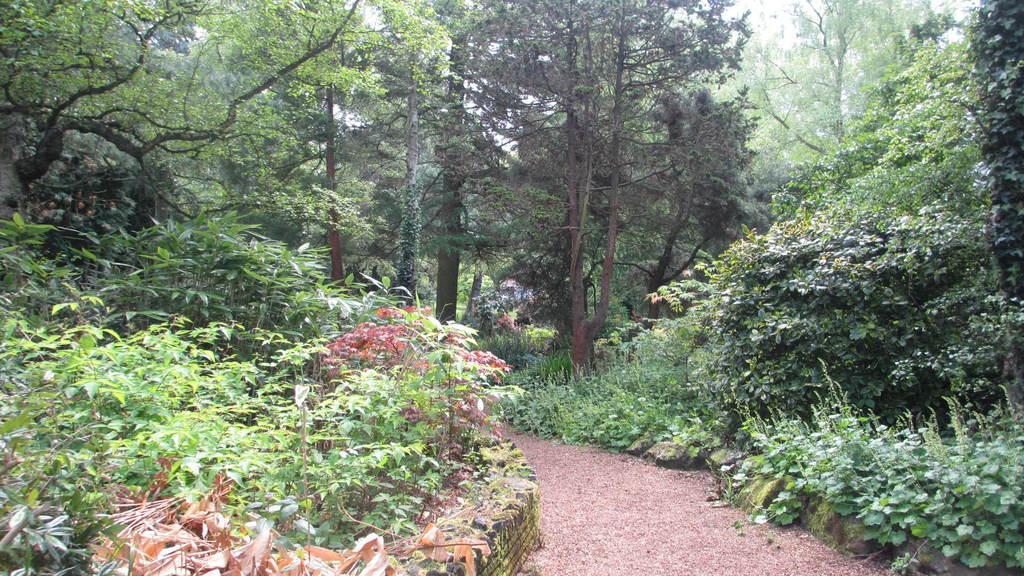What is located at the bottom side of the image? There is a path or way at the bottom side of the image. What can be observed in the surroundings of the image? There is greenery around the area of the image. What type of fork can be seen in the image? There is no fork present in the image. 